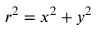<formula> <loc_0><loc_0><loc_500><loc_500>r ^ { 2 } = { x } ^ { 2 } + { y } ^ { 2 }</formula> 